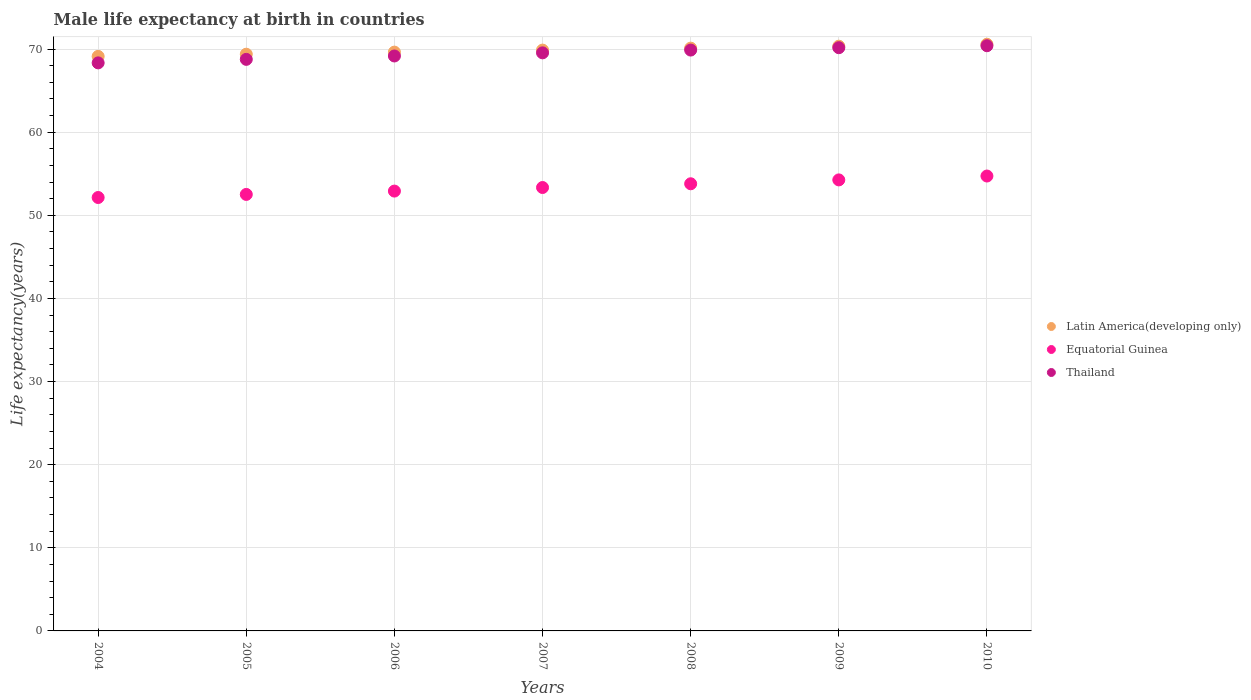Is the number of dotlines equal to the number of legend labels?
Your answer should be compact. Yes. What is the male life expectancy at birth in Latin America(developing only) in 2005?
Offer a terse response. 69.39. Across all years, what is the maximum male life expectancy at birth in Latin America(developing only)?
Give a very brief answer. 70.59. Across all years, what is the minimum male life expectancy at birth in Thailand?
Your answer should be compact. 68.34. What is the total male life expectancy at birth in Latin America(developing only) in the graph?
Offer a very short reply. 489.1. What is the difference between the male life expectancy at birth in Latin America(developing only) in 2006 and that in 2007?
Provide a short and direct response. -0.24. What is the difference between the male life expectancy at birth in Latin America(developing only) in 2005 and the male life expectancy at birth in Thailand in 2010?
Make the answer very short. -1.02. What is the average male life expectancy at birth in Thailand per year?
Offer a terse response. 69.47. In the year 2005, what is the difference between the male life expectancy at birth in Latin America(developing only) and male life expectancy at birth in Thailand?
Provide a short and direct response. 0.62. What is the ratio of the male life expectancy at birth in Thailand in 2007 to that in 2008?
Provide a succinct answer. 1. Is the male life expectancy at birth in Equatorial Guinea in 2005 less than that in 2008?
Give a very brief answer. Yes. What is the difference between the highest and the second highest male life expectancy at birth in Latin America(developing only)?
Give a very brief answer. 0.23. What is the difference between the highest and the lowest male life expectancy at birth in Thailand?
Your answer should be compact. 2.06. In how many years, is the male life expectancy at birth in Equatorial Guinea greater than the average male life expectancy at birth in Equatorial Guinea taken over all years?
Offer a terse response. 3. Is the sum of the male life expectancy at birth in Equatorial Guinea in 2004 and 2009 greater than the maximum male life expectancy at birth in Thailand across all years?
Offer a terse response. Yes. Is it the case that in every year, the sum of the male life expectancy at birth in Latin America(developing only) and male life expectancy at birth in Equatorial Guinea  is greater than the male life expectancy at birth in Thailand?
Your answer should be very brief. Yes. Is the male life expectancy at birth in Thailand strictly greater than the male life expectancy at birth in Equatorial Guinea over the years?
Make the answer very short. Yes. Is the male life expectancy at birth in Latin America(developing only) strictly less than the male life expectancy at birth in Equatorial Guinea over the years?
Make the answer very short. No. How many years are there in the graph?
Your response must be concise. 7. What is the difference between two consecutive major ticks on the Y-axis?
Your answer should be compact. 10. How many legend labels are there?
Provide a short and direct response. 3. How are the legend labels stacked?
Offer a very short reply. Vertical. What is the title of the graph?
Offer a very short reply. Male life expectancy at birth in countries. What is the label or title of the X-axis?
Ensure brevity in your answer.  Years. What is the label or title of the Y-axis?
Your answer should be very brief. Life expectancy(years). What is the Life expectancy(years) of Latin America(developing only) in 2004?
Provide a succinct answer. 69.13. What is the Life expectancy(years) in Equatorial Guinea in 2004?
Provide a succinct answer. 52.15. What is the Life expectancy(years) of Thailand in 2004?
Give a very brief answer. 68.34. What is the Life expectancy(years) of Latin America(developing only) in 2005?
Keep it short and to the point. 69.39. What is the Life expectancy(years) in Equatorial Guinea in 2005?
Give a very brief answer. 52.52. What is the Life expectancy(years) of Thailand in 2005?
Your answer should be compact. 68.77. What is the Life expectancy(years) of Latin America(developing only) in 2006?
Give a very brief answer. 69.64. What is the Life expectancy(years) in Equatorial Guinea in 2006?
Your answer should be very brief. 52.92. What is the Life expectancy(years) of Thailand in 2006?
Your answer should be compact. 69.17. What is the Life expectancy(years) in Latin America(developing only) in 2007?
Your response must be concise. 69.88. What is the Life expectancy(years) in Equatorial Guinea in 2007?
Your answer should be compact. 53.35. What is the Life expectancy(years) of Thailand in 2007?
Ensure brevity in your answer.  69.55. What is the Life expectancy(years) of Latin America(developing only) in 2008?
Provide a short and direct response. 70.12. What is the Life expectancy(years) of Equatorial Guinea in 2008?
Your answer should be compact. 53.8. What is the Life expectancy(years) in Thailand in 2008?
Your answer should be very brief. 69.89. What is the Life expectancy(years) of Latin America(developing only) in 2009?
Offer a terse response. 70.35. What is the Life expectancy(years) of Equatorial Guinea in 2009?
Your answer should be very brief. 54.27. What is the Life expectancy(years) in Thailand in 2009?
Your answer should be very brief. 70.17. What is the Life expectancy(years) of Latin America(developing only) in 2010?
Offer a terse response. 70.59. What is the Life expectancy(years) in Equatorial Guinea in 2010?
Your answer should be very brief. 54.73. What is the Life expectancy(years) in Thailand in 2010?
Ensure brevity in your answer.  70.41. Across all years, what is the maximum Life expectancy(years) of Latin America(developing only)?
Your answer should be very brief. 70.59. Across all years, what is the maximum Life expectancy(years) of Equatorial Guinea?
Give a very brief answer. 54.73. Across all years, what is the maximum Life expectancy(years) in Thailand?
Give a very brief answer. 70.41. Across all years, what is the minimum Life expectancy(years) of Latin America(developing only)?
Your response must be concise. 69.13. Across all years, what is the minimum Life expectancy(years) of Equatorial Guinea?
Make the answer very short. 52.15. Across all years, what is the minimum Life expectancy(years) in Thailand?
Offer a terse response. 68.34. What is the total Life expectancy(years) in Latin America(developing only) in the graph?
Make the answer very short. 489.1. What is the total Life expectancy(years) in Equatorial Guinea in the graph?
Offer a very short reply. 373.73. What is the total Life expectancy(years) of Thailand in the graph?
Your answer should be compact. 486.31. What is the difference between the Life expectancy(years) in Latin America(developing only) in 2004 and that in 2005?
Make the answer very short. -0.26. What is the difference between the Life expectancy(years) in Equatorial Guinea in 2004 and that in 2005?
Ensure brevity in your answer.  -0.37. What is the difference between the Life expectancy(years) of Thailand in 2004 and that in 2005?
Provide a short and direct response. -0.42. What is the difference between the Life expectancy(years) in Latin America(developing only) in 2004 and that in 2006?
Keep it short and to the point. -0.51. What is the difference between the Life expectancy(years) of Equatorial Guinea in 2004 and that in 2006?
Your answer should be compact. -0.77. What is the difference between the Life expectancy(years) in Thailand in 2004 and that in 2006?
Keep it short and to the point. -0.83. What is the difference between the Life expectancy(years) of Latin America(developing only) in 2004 and that in 2007?
Offer a terse response. -0.76. What is the difference between the Life expectancy(years) in Equatorial Guinea in 2004 and that in 2007?
Provide a short and direct response. -1.2. What is the difference between the Life expectancy(years) of Thailand in 2004 and that in 2007?
Offer a very short reply. -1.21. What is the difference between the Life expectancy(years) of Latin America(developing only) in 2004 and that in 2008?
Keep it short and to the point. -0.99. What is the difference between the Life expectancy(years) in Equatorial Guinea in 2004 and that in 2008?
Your response must be concise. -1.65. What is the difference between the Life expectancy(years) of Thailand in 2004 and that in 2008?
Give a very brief answer. -1.54. What is the difference between the Life expectancy(years) of Latin America(developing only) in 2004 and that in 2009?
Provide a succinct answer. -1.23. What is the difference between the Life expectancy(years) of Equatorial Guinea in 2004 and that in 2009?
Your answer should be compact. -2.12. What is the difference between the Life expectancy(years) of Thailand in 2004 and that in 2009?
Give a very brief answer. -1.83. What is the difference between the Life expectancy(years) of Latin America(developing only) in 2004 and that in 2010?
Your answer should be very brief. -1.46. What is the difference between the Life expectancy(years) in Equatorial Guinea in 2004 and that in 2010?
Your answer should be very brief. -2.58. What is the difference between the Life expectancy(years) in Thailand in 2004 and that in 2010?
Give a very brief answer. -2.06. What is the difference between the Life expectancy(years) of Latin America(developing only) in 2005 and that in 2006?
Offer a very short reply. -0.25. What is the difference between the Life expectancy(years) in Equatorial Guinea in 2005 and that in 2006?
Provide a succinct answer. -0.4. What is the difference between the Life expectancy(years) of Thailand in 2005 and that in 2006?
Keep it short and to the point. -0.41. What is the difference between the Life expectancy(years) in Latin America(developing only) in 2005 and that in 2007?
Give a very brief answer. -0.49. What is the difference between the Life expectancy(years) of Equatorial Guinea in 2005 and that in 2007?
Offer a very short reply. -0.83. What is the difference between the Life expectancy(years) of Thailand in 2005 and that in 2007?
Your answer should be very brief. -0.78. What is the difference between the Life expectancy(years) in Latin America(developing only) in 2005 and that in 2008?
Make the answer very short. -0.73. What is the difference between the Life expectancy(years) in Equatorial Guinea in 2005 and that in 2008?
Make the answer very short. -1.28. What is the difference between the Life expectancy(years) in Thailand in 2005 and that in 2008?
Your answer should be compact. -1.12. What is the difference between the Life expectancy(years) in Latin America(developing only) in 2005 and that in 2009?
Offer a terse response. -0.96. What is the difference between the Life expectancy(years) in Equatorial Guinea in 2005 and that in 2009?
Offer a very short reply. -1.75. What is the difference between the Life expectancy(years) of Thailand in 2005 and that in 2009?
Make the answer very short. -1.4. What is the difference between the Life expectancy(years) of Latin America(developing only) in 2005 and that in 2010?
Keep it short and to the point. -1.2. What is the difference between the Life expectancy(years) of Equatorial Guinea in 2005 and that in 2010?
Provide a short and direct response. -2.21. What is the difference between the Life expectancy(years) in Thailand in 2005 and that in 2010?
Provide a succinct answer. -1.64. What is the difference between the Life expectancy(years) of Latin America(developing only) in 2006 and that in 2007?
Offer a terse response. -0.24. What is the difference between the Life expectancy(years) of Equatorial Guinea in 2006 and that in 2007?
Keep it short and to the point. -0.43. What is the difference between the Life expectancy(years) of Thailand in 2006 and that in 2007?
Your answer should be very brief. -0.38. What is the difference between the Life expectancy(years) of Latin America(developing only) in 2006 and that in 2008?
Give a very brief answer. -0.48. What is the difference between the Life expectancy(years) of Equatorial Guinea in 2006 and that in 2008?
Your answer should be compact. -0.88. What is the difference between the Life expectancy(years) of Thailand in 2006 and that in 2008?
Offer a very short reply. -0.71. What is the difference between the Life expectancy(years) in Latin America(developing only) in 2006 and that in 2009?
Offer a terse response. -0.71. What is the difference between the Life expectancy(years) in Equatorial Guinea in 2006 and that in 2009?
Make the answer very short. -1.34. What is the difference between the Life expectancy(years) in Thailand in 2006 and that in 2009?
Make the answer very short. -1. What is the difference between the Life expectancy(years) in Latin America(developing only) in 2006 and that in 2010?
Provide a short and direct response. -0.95. What is the difference between the Life expectancy(years) of Equatorial Guinea in 2006 and that in 2010?
Provide a short and direct response. -1.81. What is the difference between the Life expectancy(years) of Thailand in 2006 and that in 2010?
Provide a succinct answer. -1.23. What is the difference between the Life expectancy(years) in Latin America(developing only) in 2007 and that in 2008?
Your response must be concise. -0.24. What is the difference between the Life expectancy(years) of Equatorial Guinea in 2007 and that in 2008?
Provide a short and direct response. -0.45. What is the difference between the Life expectancy(years) in Thailand in 2007 and that in 2008?
Make the answer very short. -0.33. What is the difference between the Life expectancy(years) in Latin America(developing only) in 2007 and that in 2009?
Your answer should be compact. -0.47. What is the difference between the Life expectancy(years) of Equatorial Guinea in 2007 and that in 2009?
Your answer should be compact. -0.92. What is the difference between the Life expectancy(years) of Thailand in 2007 and that in 2009?
Your answer should be compact. -0.62. What is the difference between the Life expectancy(years) in Latin America(developing only) in 2007 and that in 2010?
Offer a terse response. -0.71. What is the difference between the Life expectancy(years) of Equatorial Guinea in 2007 and that in 2010?
Provide a short and direct response. -1.38. What is the difference between the Life expectancy(years) of Thailand in 2007 and that in 2010?
Offer a terse response. -0.86. What is the difference between the Life expectancy(years) in Latin America(developing only) in 2008 and that in 2009?
Ensure brevity in your answer.  -0.23. What is the difference between the Life expectancy(years) in Equatorial Guinea in 2008 and that in 2009?
Give a very brief answer. -0.47. What is the difference between the Life expectancy(years) of Thailand in 2008 and that in 2009?
Your answer should be compact. -0.28. What is the difference between the Life expectancy(years) of Latin America(developing only) in 2008 and that in 2010?
Provide a succinct answer. -0.47. What is the difference between the Life expectancy(years) of Equatorial Guinea in 2008 and that in 2010?
Your response must be concise. -0.93. What is the difference between the Life expectancy(years) of Thailand in 2008 and that in 2010?
Keep it short and to the point. -0.52. What is the difference between the Life expectancy(years) in Latin America(developing only) in 2009 and that in 2010?
Give a very brief answer. -0.23. What is the difference between the Life expectancy(years) of Equatorial Guinea in 2009 and that in 2010?
Your answer should be compact. -0.47. What is the difference between the Life expectancy(years) in Thailand in 2009 and that in 2010?
Offer a very short reply. -0.24. What is the difference between the Life expectancy(years) in Latin America(developing only) in 2004 and the Life expectancy(years) in Equatorial Guinea in 2005?
Provide a short and direct response. 16.61. What is the difference between the Life expectancy(years) in Latin America(developing only) in 2004 and the Life expectancy(years) in Thailand in 2005?
Your response must be concise. 0.36. What is the difference between the Life expectancy(years) in Equatorial Guinea in 2004 and the Life expectancy(years) in Thailand in 2005?
Your answer should be very brief. -16.62. What is the difference between the Life expectancy(years) of Latin America(developing only) in 2004 and the Life expectancy(years) of Equatorial Guinea in 2006?
Your response must be concise. 16.21. What is the difference between the Life expectancy(years) of Latin America(developing only) in 2004 and the Life expectancy(years) of Thailand in 2006?
Offer a terse response. -0.05. What is the difference between the Life expectancy(years) in Equatorial Guinea in 2004 and the Life expectancy(years) in Thailand in 2006?
Your answer should be compact. -17.03. What is the difference between the Life expectancy(years) in Latin America(developing only) in 2004 and the Life expectancy(years) in Equatorial Guinea in 2007?
Make the answer very short. 15.78. What is the difference between the Life expectancy(years) of Latin America(developing only) in 2004 and the Life expectancy(years) of Thailand in 2007?
Provide a succinct answer. -0.43. What is the difference between the Life expectancy(years) in Equatorial Guinea in 2004 and the Life expectancy(years) in Thailand in 2007?
Provide a short and direct response. -17.41. What is the difference between the Life expectancy(years) in Latin America(developing only) in 2004 and the Life expectancy(years) in Equatorial Guinea in 2008?
Keep it short and to the point. 15.33. What is the difference between the Life expectancy(years) of Latin America(developing only) in 2004 and the Life expectancy(years) of Thailand in 2008?
Offer a terse response. -0.76. What is the difference between the Life expectancy(years) in Equatorial Guinea in 2004 and the Life expectancy(years) in Thailand in 2008?
Ensure brevity in your answer.  -17.74. What is the difference between the Life expectancy(years) in Latin America(developing only) in 2004 and the Life expectancy(years) in Equatorial Guinea in 2009?
Your response must be concise. 14.86. What is the difference between the Life expectancy(years) of Latin America(developing only) in 2004 and the Life expectancy(years) of Thailand in 2009?
Ensure brevity in your answer.  -1.04. What is the difference between the Life expectancy(years) of Equatorial Guinea in 2004 and the Life expectancy(years) of Thailand in 2009?
Provide a succinct answer. -18.02. What is the difference between the Life expectancy(years) in Latin America(developing only) in 2004 and the Life expectancy(years) in Equatorial Guinea in 2010?
Your answer should be very brief. 14.4. What is the difference between the Life expectancy(years) in Latin America(developing only) in 2004 and the Life expectancy(years) in Thailand in 2010?
Keep it short and to the point. -1.28. What is the difference between the Life expectancy(years) in Equatorial Guinea in 2004 and the Life expectancy(years) in Thailand in 2010?
Offer a very short reply. -18.26. What is the difference between the Life expectancy(years) in Latin America(developing only) in 2005 and the Life expectancy(years) in Equatorial Guinea in 2006?
Offer a terse response. 16.47. What is the difference between the Life expectancy(years) of Latin America(developing only) in 2005 and the Life expectancy(years) of Thailand in 2006?
Provide a short and direct response. 0.21. What is the difference between the Life expectancy(years) of Equatorial Guinea in 2005 and the Life expectancy(years) of Thailand in 2006?
Offer a very short reply. -16.66. What is the difference between the Life expectancy(years) of Latin America(developing only) in 2005 and the Life expectancy(years) of Equatorial Guinea in 2007?
Your answer should be very brief. 16.04. What is the difference between the Life expectancy(years) in Latin America(developing only) in 2005 and the Life expectancy(years) in Thailand in 2007?
Offer a very short reply. -0.16. What is the difference between the Life expectancy(years) in Equatorial Guinea in 2005 and the Life expectancy(years) in Thailand in 2007?
Keep it short and to the point. -17.03. What is the difference between the Life expectancy(years) in Latin America(developing only) in 2005 and the Life expectancy(years) in Equatorial Guinea in 2008?
Keep it short and to the point. 15.59. What is the difference between the Life expectancy(years) in Latin America(developing only) in 2005 and the Life expectancy(years) in Thailand in 2008?
Your answer should be very brief. -0.5. What is the difference between the Life expectancy(years) of Equatorial Guinea in 2005 and the Life expectancy(years) of Thailand in 2008?
Offer a very short reply. -17.37. What is the difference between the Life expectancy(years) of Latin America(developing only) in 2005 and the Life expectancy(years) of Equatorial Guinea in 2009?
Provide a short and direct response. 15.12. What is the difference between the Life expectancy(years) in Latin America(developing only) in 2005 and the Life expectancy(years) in Thailand in 2009?
Keep it short and to the point. -0.78. What is the difference between the Life expectancy(years) in Equatorial Guinea in 2005 and the Life expectancy(years) in Thailand in 2009?
Offer a terse response. -17.65. What is the difference between the Life expectancy(years) in Latin America(developing only) in 2005 and the Life expectancy(years) in Equatorial Guinea in 2010?
Ensure brevity in your answer.  14.66. What is the difference between the Life expectancy(years) in Latin America(developing only) in 2005 and the Life expectancy(years) in Thailand in 2010?
Keep it short and to the point. -1.02. What is the difference between the Life expectancy(years) in Equatorial Guinea in 2005 and the Life expectancy(years) in Thailand in 2010?
Ensure brevity in your answer.  -17.89. What is the difference between the Life expectancy(years) of Latin America(developing only) in 2006 and the Life expectancy(years) of Equatorial Guinea in 2007?
Provide a short and direct response. 16.29. What is the difference between the Life expectancy(years) of Latin America(developing only) in 2006 and the Life expectancy(years) of Thailand in 2007?
Ensure brevity in your answer.  0.09. What is the difference between the Life expectancy(years) in Equatorial Guinea in 2006 and the Life expectancy(years) in Thailand in 2007?
Provide a short and direct response. -16.63. What is the difference between the Life expectancy(years) of Latin America(developing only) in 2006 and the Life expectancy(years) of Equatorial Guinea in 2008?
Your answer should be very brief. 15.84. What is the difference between the Life expectancy(years) of Latin America(developing only) in 2006 and the Life expectancy(years) of Thailand in 2008?
Offer a terse response. -0.25. What is the difference between the Life expectancy(years) of Equatorial Guinea in 2006 and the Life expectancy(years) of Thailand in 2008?
Your answer should be compact. -16.97. What is the difference between the Life expectancy(years) of Latin America(developing only) in 2006 and the Life expectancy(years) of Equatorial Guinea in 2009?
Your response must be concise. 15.37. What is the difference between the Life expectancy(years) in Latin America(developing only) in 2006 and the Life expectancy(years) in Thailand in 2009?
Make the answer very short. -0.53. What is the difference between the Life expectancy(years) of Equatorial Guinea in 2006 and the Life expectancy(years) of Thailand in 2009?
Your answer should be very brief. -17.25. What is the difference between the Life expectancy(years) in Latin America(developing only) in 2006 and the Life expectancy(years) in Equatorial Guinea in 2010?
Provide a succinct answer. 14.91. What is the difference between the Life expectancy(years) in Latin America(developing only) in 2006 and the Life expectancy(years) in Thailand in 2010?
Make the answer very short. -0.77. What is the difference between the Life expectancy(years) in Equatorial Guinea in 2006 and the Life expectancy(years) in Thailand in 2010?
Your answer should be very brief. -17.49. What is the difference between the Life expectancy(years) of Latin America(developing only) in 2007 and the Life expectancy(years) of Equatorial Guinea in 2008?
Offer a very short reply. 16.08. What is the difference between the Life expectancy(years) of Latin America(developing only) in 2007 and the Life expectancy(years) of Thailand in 2008?
Your answer should be compact. -0. What is the difference between the Life expectancy(years) in Equatorial Guinea in 2007 and the Life expectancy(years) in Thailand in 2008?
Your answer should be compact. -16.54. What is the difference between the Life expectancy(years) in Latin America(developing only) in 2007 and the Life expectancy(years) in Equatorial Guinea in 2009?
Your answer should be very brief. 15.62. What is the difference between the Life expectancy(years) of Latin America(developing only) in 2007 and the Life expectancy(years) of Thailand in 2009?
Offer a terse response. -0.29. What is the difference between the Life expectancy(years) in Equatorial Guinea in 2007 and the Life expectancy(years) in Thailand in 2009?
Your answer should be very brief. -16.82. What is the difference between the Life expectancy(years) of Latin America(developing only) in 2007 and the Life expectancy(years) of Equatorial Guinea in 2010?
Provide a short and direct response. 15.15. What is the difference between the Life expectancy(years) of Latin America(developing only) in 2007 and the Life expectancy(years) of Thailand in 2010?
Make the answer very short. -0.53. What is the difference between the Life expectancy(years) of Equatorial Guinea in 2007 and the Life expectancy(years) of Thailand in 2010?
Make the answer very short. -17.06. What is the difference between the Life expectancy(years) of Latin America(developing only) in 2008 and the Life expectancy(years) of Equatorial Guinea in 2009?
Offer a very short reply. 15.85. What is the difference between the Life expectancy(years) of Latin America(developing only) in 2008 and the Life expectancy(years) of Thailand in 2009?
Offer a terse response. -0.05. What is the difference between the Life expectancy(years) in Equatorial Guinea in 2008 and the Life expectancy(years) in Thailand in 2009?
Ensure brevity in your answer.  -16.37. What is the difference between the Life expectancy(years) in Latin America(developing only) in 2008 and the Life expectancy(years) in Equatorial Guinea in 2010?
Make the answer very short. 15.39. What is the difference between the Life expectancy(years) in Latin America(developing only) in 2008 and the Life expectancy(years) in Thailand in 2010?
Give a very brief answer. -0.29. What is the difference between the Life expectancy(years) in Equatorial Guinea in 2008 and the Life expectancy(years) in Thailand in 2010?
Ensure brevity in your answer.  -16.61. What is the difference between the Life expectancy(years) of Latin America(developing only) in 2009 and the Life expectancy(years) of Equatorial Guinea in 2010?
Offer a terse response. 15.62. What is the difference between the Life expectancy(years) in Latin America(developing only) in 2009 and the Life expectancy(years) in Thailand in 2010?
Offer a terse response. -0.06. What is the difference between the Life expectancy(years) of Equatorial Guinea in 2009 and the Life expectancy(years) of Thailand in 2010?
Provide a succinct answer. -16.14. What is the average Life expectancy(years) in Latin America(developing only) per year?
Your response must be concise. 69.87. What is the average Life expectancy(years) of Equatorial Guinea per year?
Your answer should be compact. 53.39. What is the average Life expectancy(years) of Thailand per year?
Give a very brief answer. 69.47. In the year 2004, what is the difference between the Life expectancy(years) in Latin America(developing only) and Life expectancy(years) in Equatorial Guinea?
Keep it short and to the point. 16.98. In the year 2004, what is the difference between the Life expectancy(years) in Latin America(developing only) and Life expectancy(years) in Thailand?
Provide a short and direct response. 0.78. In the year 2004, what is the difference between the Life expectancy(years) of Equatorial Guinea and Life expectancy(years) of Thailand?
Your answer should be very brief. -16.2. In the year 2005, what is the difference between the Life expectancy(years) of Latin America(developing only) and Life expectancy(years) of Equatorial Guinea?
Offer a terse response. 16.87. In the year 2005, what is the difference between the Life expectancy(years) in Latin America(developing only) and Life expectancy(years) in Thailand?
Your answer should be very brief. 0.62. In the year 2005, what is the difference between the Life expectancy(years) in Equatorial Guinea and Life expectancy(years) in Thailand?
Offer a terse response. -16.25. In the year 2006, what is the difference between the Life expectancy(years) of Latin America(developing only) and Life expectancy(years) of Equatorial Guinea?
Make the answer very short. 16.72. In the year 2006, what is the difference between the Life expectancy(years) in Latin America(developing only) and Life expectancy(years) in Thailand?
Give a very brief answer. 0.46. In the year 2006, what is the difference between the Life expectancy(years) in Equatorial Guinea and Life expectancy(years) in Thailand?
Give a very brief answer. -16.25. In the year 2007, what is the difference between the Life expectancy(years) of Latin America(developing only) and Life expectancy(years) of Equatorial Guinea?
Your response must be concise. 16.53. In the year 2007, what is the difference between the Life expectancy(years) in Latin America(developing only) and Life expectancy(years) in Thailand?
Provide a succinct answer. 0.33. In the year 2007, what is the difference between the Life expectancy(years) in Equatorial Guinea and Life expectancy(years) in Thailand?
Your answer should be very brief. -16.2. In the year 2008, what is the difference between the Life expectancy(years) in Latin America(developing only) and Life expectancy(years) in Equatorial Guinea?
Your answer should be very brief. 16.32. In the year 2008, what is the difference between the Life expectancy(years) in Latin America(developing only) and Life expectancy(years) in Thailand?
Make the answer very short. 0.23. In the year 2008, what is the difference between the Life expectancy(years) in Equatorial Guinea and Life expectancy(years) in Thailand?
Your answer should be compact. -16.09. In the year 2009, what is the difference between the Life expectancy(years) in Latin America(developing only) and Life expectancy(years) in Equatorial Guinea?
Your answer should be compact. 16.09. In the year 2009, what is the difference between the Life expectancy(years) of Latin America(developing only) and Life expectancy(years) of Thailand?
Give a very brief answer. 0.18. In the year 2009, what is the difference between the Life expectancy(years) in Equatorial Guinea and Life expectancy(years) in Thailand?
Ensure brevity in your answer.  -15.91. In the year 2010, what is the difference between the Life expectancy(years) in Latin America(developing only) and Life expectancy(years) in Equatorial Guinea?
Give a very brief answer. 15.86. In the year 2010, what is the difference between the Life expectancy(years) in Latin America(developing only) and Life expectancy(years) in Thailand?
Make the answer very short. 0.18. In the year 2010, what is the difference between the Life expectancy(years) in Equatorial Guinea and Life expectancy(years) in Thailand?
Offer a very short reply. -15.68. What is the ratio of the Life expectancy(years) of Latin America(developing only) in 2004 to that in 2005?
Your answer should be compact. 1. What is the ratio of the Life expectancy(years) in Thailand in 2004 to that in 2005?
Offer a terse response. 0.99. What is the ratio of the Life expectancy(years) in Equatorial Guinea in 2004 to that in 2006?
Keep it short and to the point. 0.99. What is the ratio of the Life expectancy(years) of Thailand in 2004 to that in 2006?
Keep it short and to the point. 0.99. What is the ratio of the Life expectancy(years) of Equatorial Guinea in 2004 to that in 2007?
Provide a succinct answer. 0.98. What is the ratio of the Life expectancy(years) of Thailand in 2004 to that in 2007?
Your answer should be very brief. 0.98. What is the ratio of the Life expectancy(years) of Latin America(developing only) in 2004 to that in 2008?
Your answer should be very brief. 0.99. What is the ratio of the Life expectancy(years) in Equatorial Guinea in 2004 to that in 2008?
Make the answer very short. 0.97. What is the ratio of the Life expectancy(years) of Thailand in 2004 to that in 2008?
Provide a succinct answer. 0.98. What is the ratio of the Life expectancy(years) of Latin America(developing only) in 2004 to that in 2009?
Your answer should be very brief. 0.98. What is the ratio of the Life expectancy(years) in Equatorial Guinea in 2004 to that in 2009?
Provide a short and direct response. 0.96. What is the ratio of the Life expectancy(years) of Latin America(developing only) in 2004 to that in 2010?
Your answer should be very brief. 0.98. What is the ratio of the Life expectancy(years) of Equatorial Guinea in 2004 to that in 2010?
Your answer should be compact. 0.95. What is the ratio of the Life expectancy(years) of Thailand in 2004 to that in 2010?
Your response must be concise. 0.97. What is the ratio of the Life expectancy(years) in Thailand in 2005 to that in 2006?
Offer a very short reply. 0.99. What is the ratio of the Life expectancy(years) in Latin America(developing only) in 2005 to that in 2007?
Ensure brevity in your answer.  0.99. What is the ratio of the Life expectancy(years) in Equatorial Guinea in 2005 to that in 2007?
Offer a terse response. 0.98. What is the ratio of the Life expectancy(years) of Thailand in 2005 to that in 2007?
Make the answer very short. 0.99. What is the ratio of the Life expectancy(years) in Equatorial Guinea in 2005 to that in 2008?
Offer a very short reply. 0.98. What is the ratio of the Life expectancy(years) in Thailand in 2005 to that in 2008?
Offer a very short reply. 0.98. What is the ratio of the Life expectancy(years) of Latin America(developing only) in 2005 to that in 2009?
Offer a terse response. 0.99. What is the ratio of the Life expectancy(years) in Equatorial Guinea in 2005 to that in 2009?
Your answer should be compact. 0.97. What is the ratio of the Life expectancy(years) of Latin America(developing only) in 2005 to that in 2010?
Keep it short and to the point. 0.98. What is the ratio of the Life expectancy(years) of Equatorial Guinea in 2005 to that in 2010?
Your answer should be compact. 0.96. What is the ratio of the Life expectancy(years) in Thailand in 2005 to that in 2010?
Your response must be concise. 0.98. What is the ratio of the Life expectancy(years) of Latin America(developing only) in 2006 to that in 2008?
Ensure brevity in your answer.  0.99. What is the ratio of the Life expectancy(years) of Equatorial Guinea in 2006 to that in 2008?
Your answer should be compact. 0.98. What is the ratio of the Life expectancy(years) of Thailand in 2006 to that in 2008?
Offer a very short reply. 0.99. What is the ratio of the Life expectancy(years) of Latin America(developing only) in 2006 to that in 2009?
Your answer should be compact. 0.99. What is the ratio of the Life expectancy(years) of Equatorial Guinea in 2006 to that in 2009?
Make the answer very short. 0.98. What is the ratio of the Life expectancy(years) in Thailand in 2006 to that in 2009?
Your answer should be compact. 0.99. What is the ratio of the Life expectancy(years) in Latin America(developing only) in 2006 to that in 2010?
Offer a very short reply. 0.99. What is the ratio of the Life expectancy(years) in Equatorial Guinea in 2006 to that in 2010?
Your response must be concise. 0.97. What is the ratio of the Life expectancy(years) in Thailand in 2006 to that in 2010?
Offer a very short reply. 0.98. What is the ratio of the Life expectancy(years) of Equatorial Guinea in 2007 to that in 2009?
Offer a terse response. 0.98. What is the ratio of the Life expectancy(years) of Thailand in 2007 to that in 2009?
Provide a short and direct response. 0.99. What is the ratio of the Life expectancy(years) in Latin America(developing only) in 2007 to that in 2010?
Your answer should be compact. 0.99. What is the ratio of the Life expectancy(years) in Equatorial Guinea in 2007 to that in 2010?
Make the answer very short. 0.97. What is the ratio of the Life expectancy(years) in Thailand in 2007 to that in 2010?
Make the answer very short. 0.99. What is the ratio of the Life expectancy(years) in Latin America(developing only) in 2008 to that in 2009?
Provide a succinct answer. 1. What is the ratio of the Life expectancy(years) in Latin America(developing only) in 2008 to that in 2010?
Provide a succinct answer. 0.99. What is the ratio of the Life expectancy(years) in Equatorial Guinea in 2008 to that in 2010?
Your answer should be very brief. 0.98. What is the ratio of the Life expectancy(years) of Thailand in 2008 to that in 2010?
Ensure brevity in your answer.  0.99. What is the ratio of the Life expectancy(years) in Latin America(developing only) in 2009 to that in 2010?
Ensure brevity in your answer.  1. What is the ratio of the Life expectancy(years) in Thailand in 2009 to that in 2010?
Your answer should be very brief. 1. What is the difference between the highest and the second highest Life expectancy(years) in Latin America(developing only)?
Make the answer very short. 0.23. What is the difference between the highest and the second highest Life expectancy(years) of Equatorial Guinea?
Give a very brief answer. 0.47. What is the difference between the highest and the second highest Life expectancy(years) in Thailand?
Your answer should be compact. 0.24. What is the difference between the highest and the lowest Life expectancy(years) in Latin America(developing only)?
Offer a terse response. 1.46. What is the difference between the highest and the lowest Life expectancy(years) of Equatorial Guinea?
Ensure brevity in your answer.  2.58. What is the difference between the highest and the lowest Life expectancy(years) in Thailand?
Your answer should be very brief. 2.06. 